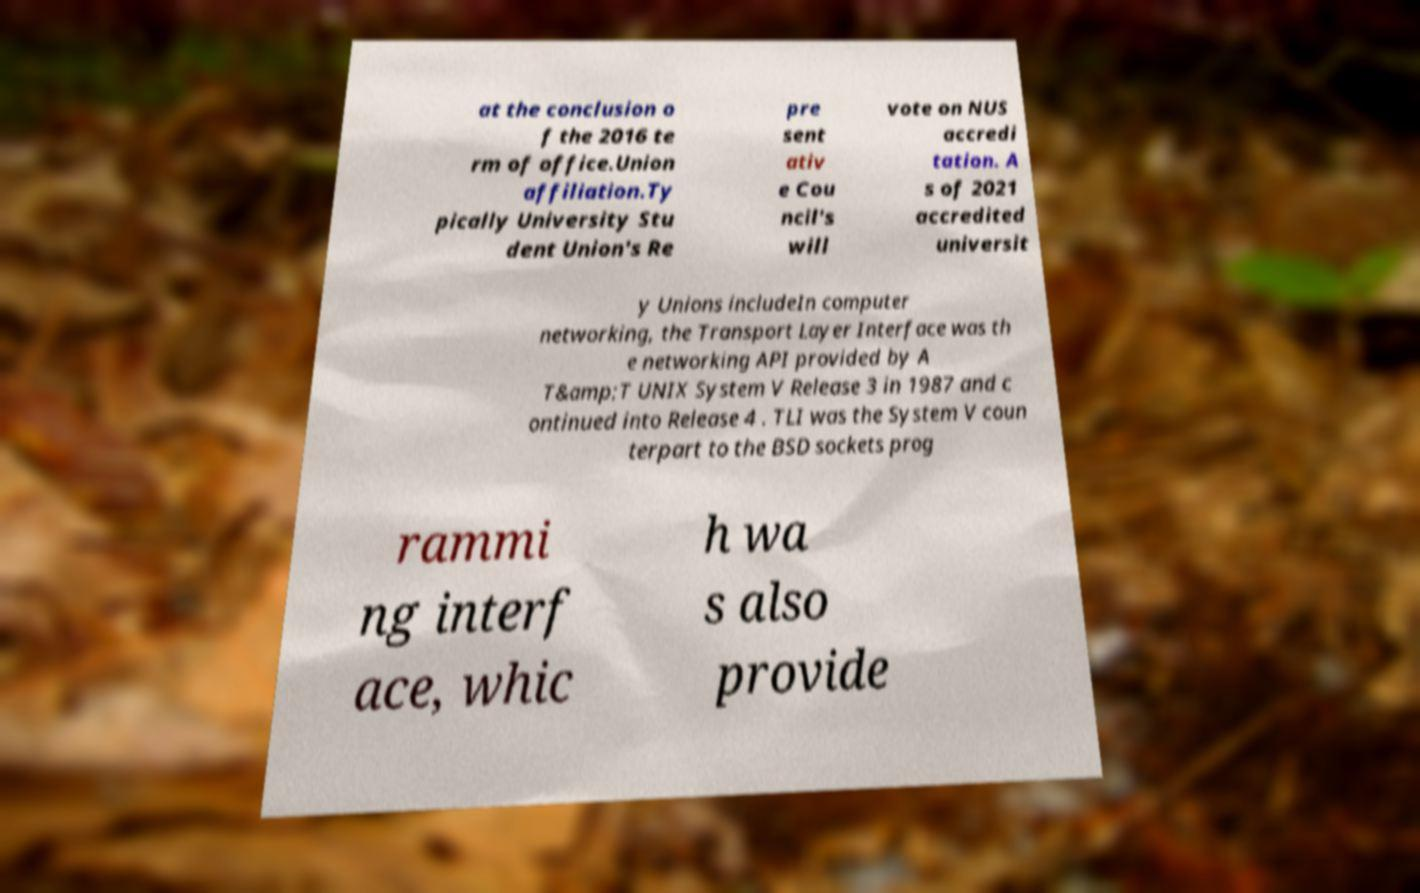What messages or text are displayed in this image? I need them in a readable, typed format. at the conclusion o f the 2016 te rm of office.Union affiliation.Ty pically University Stu dent Union's Re pre sent ativ e Cou ncil's will vote on NUS accredi tation. A s of 2021 accredited universit y Unions includeIn computer networking, the Transport Layer Interface was th e networking API provided by A T&amp;T UNIX System V Release 3 in 1987 and c ontinued into Release 4 . TLI was the System V coun terpart to the BSD sockets prog rammi ng interf ace, whic h wa s also provide 